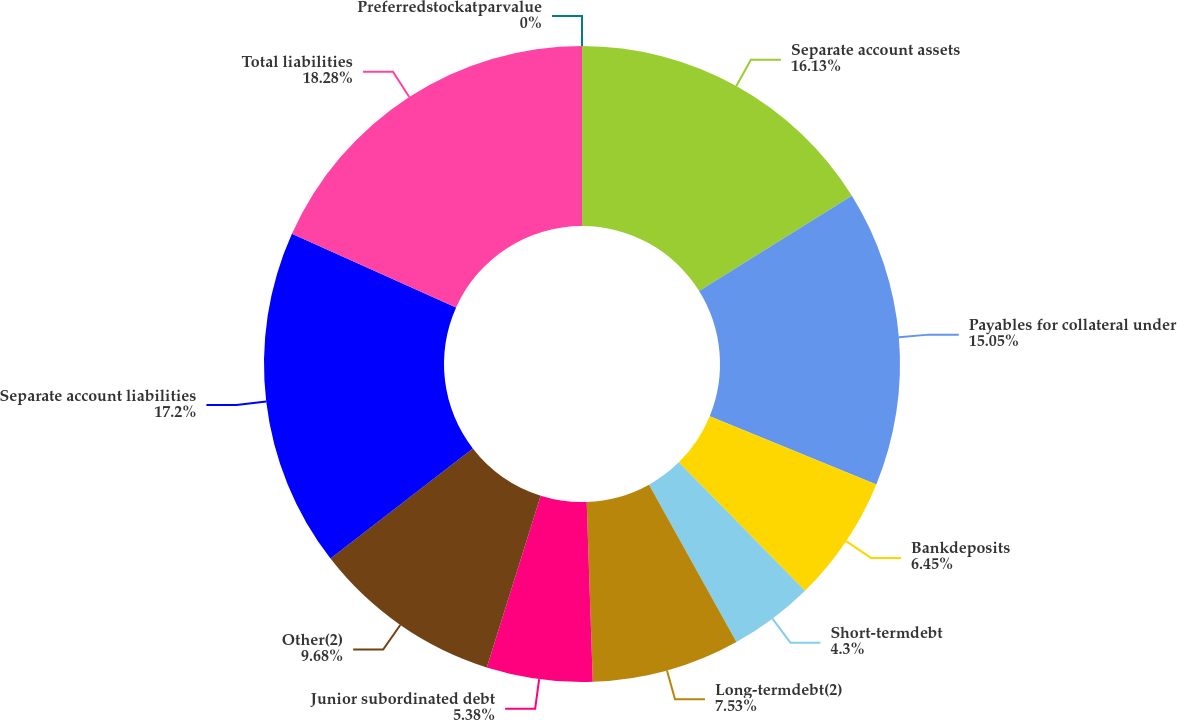<chart> <loc_0><loc_0><loc_500><loc_500><pie_chart><fcel>Separate account assets<fcel>Payables for collateral under<fcel>Bankdeposits<fcel>Short-termdebt<fcel>Long-termdebt(2)<fcel>Junior subordinated debt<fcel>Other(2)<fcel>Separate account liabilities<fcel>Total liabilities<fcel>Preferredstockatparvalue<nl><fcel>16.13%<fcel>15.05%<fcel>6.45%<fcel>4.3%<fcel>7.53%<fcel>5.38%<fcel>9.68%<fcel>17.2%<fcel>18.28%<fcel>0.0%<nl></chart> 